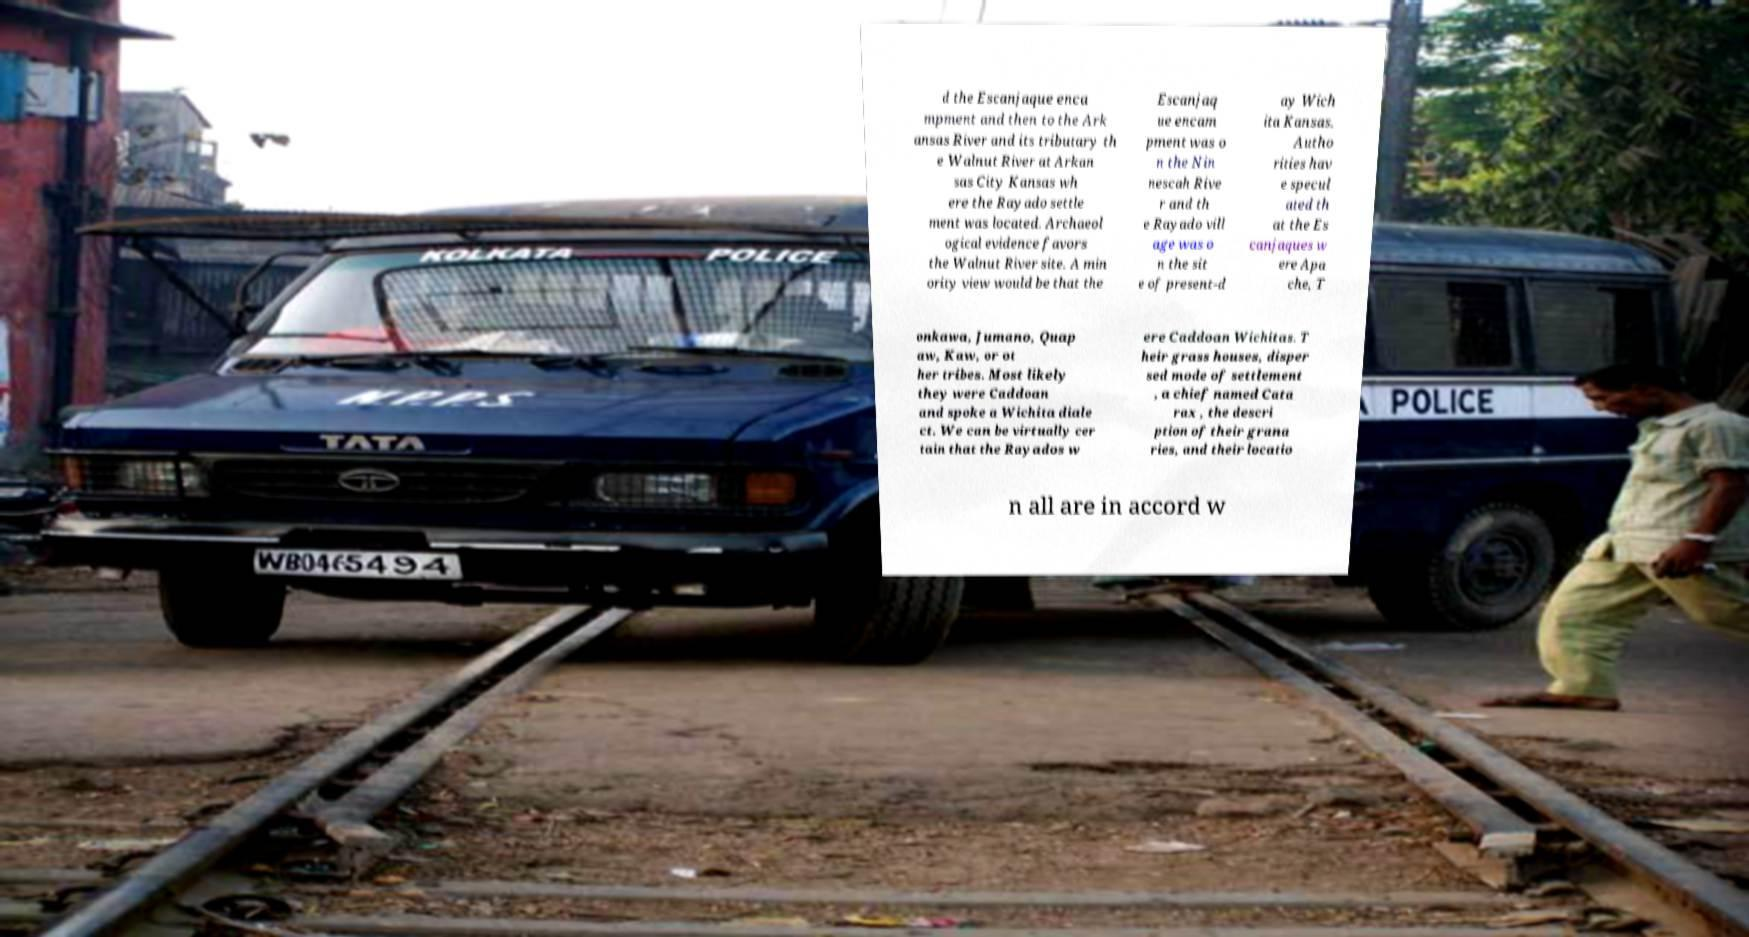There's text embedded in this image that I need extracted. Can you transcribe it verbatim? d the Escanjaque enca mpment and then to the Ark ansas River and its tributary th e Walnut River at Arkan sas City Kansas wh ere the Rayado settle ment was located. Archaeol ogical evidence favors the Walnut River site. A min ority view would be that the Escanjaq ue encam pment was o n the Nin nescah Rive r and th e Rayado vill age was o n the sit e of present-d ay Wich ita Kansas. Autho rities hav e specul ated th at the Es canjaques w ere Apa che, T onkawa, Jumano, Quap aw, Kaw, or ot her tribes. Most likely they were Caddoan and spoke a Wichita diale ct. We can be virtually cer tain that the Rayados w ere Caddoan Wichitas. T heir grass houses, disper sed mode of settlement , a chief named Cata rax , the descri ption of their grana ries, and their locatio n all are in accord w 